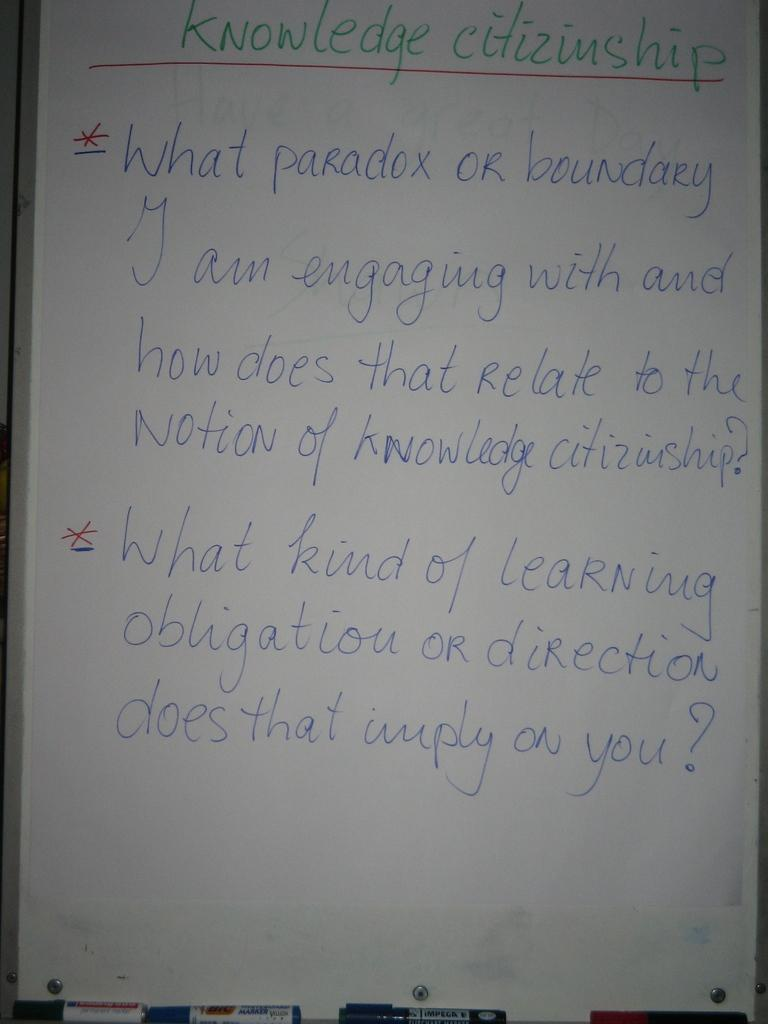<image>
Relay a brief, clear account of the picture shown. Notes about knowledge citizenship are marked with red asterisks. 